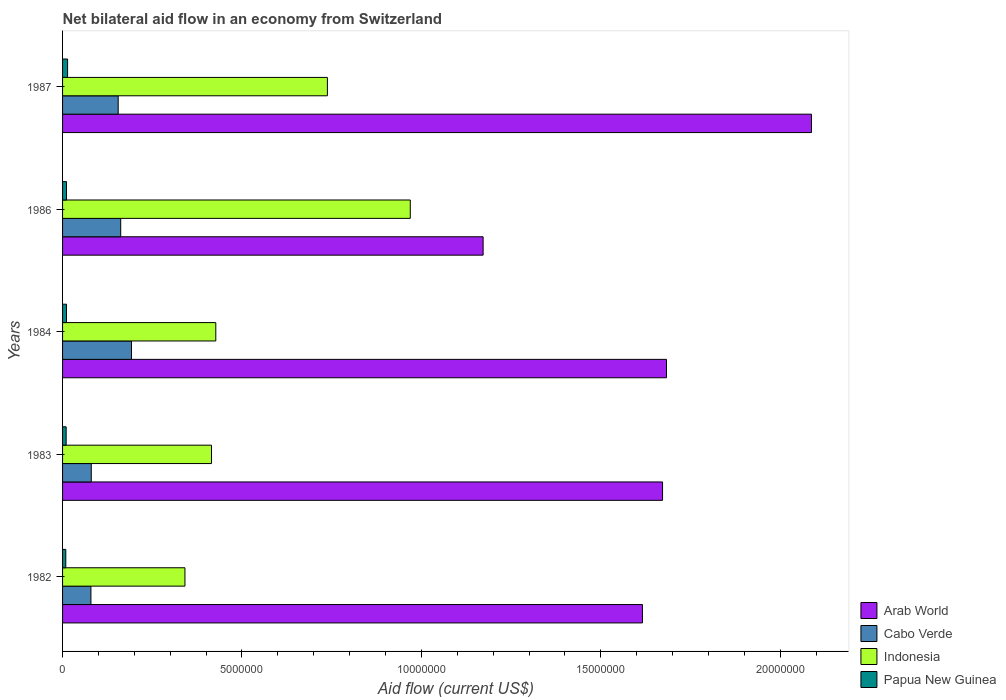How many different coloured bars are there?
Your response must be concise. 4. How many groups of bars are there?
Provide a succinct answer. 5. Are the number of bars on each tick of the Y-axis equal?
Your answer should be compact. Yes. In how many cases, is the number of bars for a given year not equal to the number of legend labels?
Your response must be concise. 0. What is the net bilateral aid flow in Arab World in 1987?
Your response must be concise. 2.09e+07. Across all years, what is the maximum net bilateral aid flow in Indonesia?
Keep it short and to the point. 9.69e+06. Across all years, what is the minimum net bilateral aid flow in Arab World?
Make the answer very short. 1.17e+07. In which year was the net bilateral aid flow in Papua New Guinea maximum?
Your response must be concise. 1987. What is the total net bilateral aid flow in Cabo Verde in the graph?
Provide a succinct answer. 6.68e+06. What is the difference between the net bilateral aid flow in Cabo Verde in 1987 and the net bilateral aid flow in Arab World in 1982?
Ensure brevity in your answer.  -1.46e+07. What is the average net bilateral aid flow in Indonesia per year?
Provide a short and direct response. 5.78e+06. In the year 1986, what is the difference between the net bilateral aid flow in Arab World and net bilateral aid flow in Papua New Guinea?
Ensure brevity in your answer.  1.16e+07. What is the ratio of the net bilateral aid flow in Arab World in 1984 to that in 1987?
Provide a succinct answer. 0.81. What is the difference between the highest and the second highest net bilateral aid flow in Cabo Verde?
Provide a short and direct response. 3.00e+05. What is the difference between the highest and the lowest net bilateral aid flow in Cabo Verde?
Offer a terse response. 1.13e+06. In how many years, is the net bilateral aid flow in Arab World greater than the average net bilateral aid flow in Arab World taken over all years?
Give a very brief answer. 3. Is the sum of the net bilateral aid flow in Cabo Verde in 1983 and 1987 greater than the maximum net bilateral aid flow in Papua New Guinea across all years?
Keep it short and to the point. Yes. Is it the case that in every year, the sum of the net bilateral aid flow in Papua New Guinea and net bilateral aid flow in Indonesia is greater than the sum of net bilateral aid flow in Arab World and net bilateral aid flow in Cabo Verde?
Your answer should be very brief. Yes. What does the 4th bar from the top in 1987 represents?
Give a very brief answer. Arab World. What does the 1st bar from the bottom in 1987 represents?
Give a very brief answer. Arab World. Is it the case that in every year, the sum of the net bilateral aid flow in Indonesia and net bilateral aid flow in Cabo Verde is greater than the net bilateral aid flow in Arab World?
Offer a very short reply. No. What is the difference between two consecutive major ticks on the X-axis?
Provide a short and direct response. 5.00e+06. Does the graph contain any zero values?
Make the answer very short. No. Where does the legend appear in the graph?
Your answer should be very brief. Bottom right. How many legend labels are there?
Ensure brevity in your answer.  4. How are the legend labels stacked?
Offer a terse response. Vertical. What is the title of the graph?
Keep it short and to the point. Net bilateral aid flow in an economy from Switzerland. What is the label or title of the Y-axis?
Your answer should be very brief. Years. What is the Aid flow (current US$) of Arab World in 1982?
Offer a very short reply. 1.62e+07. What is the Aid flow (current US$) in Cabo Verde in 1982?
Offer a terse response. 7.90e+05. What is the Aid flow (current US$) of Indonesia in 1982?
Ensure brevity in your answer.  3.41e+06. What is the Aid flow (current US$) in Papua New Guinea in 1982?
Offer a terse response. 9.00e+04. What is the Aid flow (current US$) of Arab World in 1983?
Ensure brevity in your answer.  1.67e+07. What is the Aid flow (current US$) of Indonesia in 1983?
Your answer should be compact. 4.15e+06. What is the Aid flow (current US$) in Arab World in 1984?
Your answer should be compact. 1.68e+07. What is the Aid flow (current US$) of Cabo Verde in 1984?
Offer a terse response. 1.92e+06. What is the Aid flow (current US$) of Indonesia in 1984?
Your answer should be compact. 4.27e+06. What is the Aid flow (current US$) of Papua New Guinea in 1984?
Your answer should be compact. 1.10e+05. What is the Aid flow (current US$) in Arab World in 1986?
Provide a succinct answer. 1.17e+07. What is the Aid flow (current US$) in Cabo Verde in 1986?
Your answer should be very brief. 1.62e+06. What is the Aid flow (current US$) in Indonesia in 1986?
Keep it short and to the point. 9.69e+06. What is the Aid flow (current US$) in Arab World in 1987?
Ensure brevity in your answer.  2.09e+07. What is the Aid flow (current US$) in Cabo Verde in 1987?
Your response must be concise. 1.55e+06. What is the Aid flow (current US$) of Indonesia in 1987?
Make the answer very short. 7.38e+06. Across all years, what is the maximum Aid flow (current US$) in Arab World?
Your response must be concise. 2.09e+07. Across all years, what is the maximum Aid flow (current US$) of Cabo Verde?
Your response must be concise. 1.92e+06. Across all years, what is the maximum Aid flow (current US$) of Indonesia?
Provide a short and direct response. 9.69e+06. Across all years, what is the maximum Aid flow (current US$) in Papua New Guinea?
Keep it short and to the point. 1.40e+05. Across all years, what is the minimum Aid flow (current US$) of Arab World?
Provide a short and direct response. 1.17e+07. Across all years, what is the minimum Aid flow (current US$) in Cabo Verde?
Keep it short and to the point. 7.90e+05. Across all years, what is the minimum Aid flow (current US$) of Indonesia?
Make the answer very short. 3.41e+06. Across all years, what is the minimum Aid flow (current US$) of Papua New Guinea?
Make the answer very short. 9.00e+04. What is the total Aid flow (current US$) in Arab World in the graph?
Make the answer very short. 8.23e+07. What is the total Aid flow (current US$) in Cabo Verde in the graph?
Offer a terse response. 6.68e+06. What is the total Aid flow (current US$) of Indonesia in the graph?
Keep it short and to the point. 2.89e+07. What is the difference between the Aid flow (current US$) of Arab World in 1982 and that in 1983?
Provide a succinct answer. -5.60e+05. What is the difference between the Aid flow (current US$) in Indonesia in 1982 and that in 1983?
Make the answer very short. -7.40e+05. What is the difference between the Aid flow (current US$) in Arab World in 1982 and that in 1984?
Your response must be concise. -6.70e+05. What is the difference between the Aid flow (current US$) of Cabo Verde in 1982 and that in 1984?
Keep it short and to the point. -1.13e+06. What is the difference between the Aid flow (current US$) of Indonesia in 1982 and that in 1984?
Give a very brief answer. -8.60e+05. What is the difference between the Aid flow (current US$) in Arab World in 1982 and that in 1986?
Provide a succinct answer. 4.44e+06. What is the difference between the Aid flow (current US$) of Cabo Verde in 1982 and that in 1986?
Give a very brief answer. -8.30e+05. What is the difference between the Aid flow (current US$) of Indonesia in 1982 and that in 1986?
Provide a short and direct response. -6.28e+06. What is the difference between the Aid flow (current US$) in Arab World in 1982 and that in 1987?
Offer a very short reply. -4.71e+06. What is the difference between the Aid flow (current US$) in Cabo Verde in 1982 and that in 1987?
Your response must be concise. -7.60e+05. What is the difference between the Aid flow (current US$) in Indonesia in 1982 and that in 1987?
Ensure brevity in your answer.  -3.97e+06. What is the difference between the Aid flow (current US$) in Cabo Verde in 1983 and that in 1984?
Make the answer very short. -1.12e+06. What is the difference between the Aid flow (current US$) in Indonesia in 1983 and that in 1984?
Offer a terse response. -1.20e+05. What is the difference between the Aid flow (current US$) in Papua New Guinea in 1983 and that in 1984?
Provide a short and direct response. -10000. What is the difference between the Aid flow (current US$) in Cabo Verde in 1983 and that in 1986?
Keep it short and to the point. -8.20e+05. What is the difference between the Aid flow (current US$) of Indonesia in 1983 and that in 1986?
Give a very brief answer. -5.54e+06. What is the difference between the Aid flow (current US$) in Papua New Guinea in 1983 and that in 1986?
Offer a terse response. -10000. What is the difference between the Aid flow (current US$) of Arab World in 1983 and that in 1987?
Your answer should be very brief. -4.15e+06. What is the difference between the Aid flow (current US$) of Cabo Verde in 1983 and that in 1987?
Your answer should be very brief. -7.50e+05. What is the difference between the Aid flow (current US$) in Indonesia in 1983 and that in 1987?
Offer a very short reply. -3.23e+06. What is the difference between the Aid flow (current US$) in Arab World in 1984 and that in 1986?
Provide a short and direct response. 5.11e+06. What is the difference between the Aid flow (current US$) of Indonesia in 1984 and that in 1986?
Your response must be concise. -5.42e+06. What is the difference between the Aid flow (current US$) in Papua New Guinea in 1984 and that in 1986?
Offer a very short reply. 0. What is the difference between the Aid flow (current US$) of Arab World in 1984 and that in 1987?
Your answer should be very brief. -4.04e+06. What is the difference between the Aid flow (current US$) in Indonesia in 1984 and that in 1987?
Make the answer very short. -3.11e+06. What is the difference between the Aid flow (current US$) in Papua New Guinea in 1984 and that in 1987?
Keep it short and to the point. -3.00e+04. What is the difference between the Aid flow (current US$) of Arab World in 1986 and that in 1987?
Ensure brevity in your answer.  -9.15e+06. What is the difference between the Aid flow (current US$) of Indonesia in 1986 and that in 1987?
Provide a succinct answer. 2.31e+06. What is the difference between the Aid flow (current US$) in Papua New Guinea in 1986 and that in 1987?
Offer a very short reply. -3.00e+04. What is the difference between the Aid flow (current US$) of Arab World in 1982 and the Aid flow (current US$) of Cabo Verde in 1983?
Offer a very short reply. 1.54e+07. What is the difference between the Aid flow (current US$) of Arab World in 1982 and the Aid flow (current US$) of Indonesia in 1983?
Make the answer very short. 1.20e+07. What is the difference between the Aid flow (current US$) in Arab World in 1982 and the Aid flow (current US$) in Papua New Guinea in 1983?
Make the answer very short. 1.61e+07. What is the difference between the Aid flow (current US$) of Cabo Verde in 1982 and the Aid flow (current US$) of Indonesia in 1983?
Your answer should be compact. -3.36e+06. What is the difference between the Aid flow (current US$) of Cabo Verde in 1982 and the Aid flow (current US$) of Papua New Guinea in 1983?
Ensure brevity in your answer.  6.90e+05. What is the difference between the Aid flow (current US$) of Indonesia in 1982 and the Aid flow (current US$) of Papua New Guinea in 1983?
Make the answer very short. 3.31e+06. What is the difference between the Aid flow (current US$) of Arab World in 1982 and the Aid flow (current US$) of Cabo Verde in 1984?
Provide a succinct answer. 1.42e+07. What is the difference between the Aid flow (current US$) in Arab World in 1982 and the Aid flow (current US$) in Indonesia in 1984?
Provide a short and direct response. 1.19e+07. What is the difference between the Aid flow (current US$) in Arab World in 1982 and the Aid flow (current US$) in Papua New Guinea in 1984?
Ensure brevity in your answer.  1.60e+07. What is the difference between the Aid flow (current US$) in Cabo Verde in 1982 and the Aid flow (current US$) in Indonesia in 1984?
Your response must be concise. -3.48e+06. What is the difference between the Aid flow (current US$) of Cabo Verde in 1982 and the Aid flow (current US$) of Papua New Guinea in 1984?
Keep it short and to the point. 6.80e+05. What is the difference between the Aid flow (current US$) of Indonesia in 1982 and the Aid flow (current US$) of Papua New Guinea in 1984?
Your answer should be compact. 3.30e+06. What is the difference between the Aid flow (current US$) in Arab World in 1982 and the Aid flow (current US$) in Cabo Verde in 1986?
Offer a very short reply. 1.45e+07. What is the difference between the Aid flow (current US$) in Arab World in 1982 and the Aid flow (current US$) in Indonesia in 1986?
Offer a terse response. 6.47e+06. What is the difference between the Aid flow (current US$) of Arab World in 1982 and the Aid flow (current US$) of Papua New Guinea in 1986?
Offer a terse response. 1.60e+07. What is the difference between the Aid flow (current US$) in Cabo Verde in 1982 and the Aid flow (current US$) in Indonesia in 1986?
Your answer should be very brief. -8.90e+06. What is the difference between the Aid flow (current US$) in Cabo Verde in 1982 and the Aid flow (current US$) in Papua New Guinea in 1986?
Your answer should be very brief. 6.80e+05. What is the difference between the Aid flow (current US$) in Indonesia in 1982 and the Aid flow (current US$) in Papua New Guinea in 1986?
Your answer should be very brief. 3.30e+06. What is the difference between the Aid flow (current US$) in Arab World in 1982 and the Aid flow (current US$) in Cabo Verde in 1987?
Give a very brief answer. 1.46e+07. What is the difference between the Aid flow (current US$) in Arab World in 1982 and the Aid flow (current US$) in Indonesia in 1987?
Your response must be concise. 8.78e+06. What is the difference between the Aid flow (current US$) of Arab World in 1982 and the Aid flow (current US$) of Papua New Guinea in 1987?
Your response must be concise. 1.60e+07. What is the difference between the Aid flow (current US$) in Cabo Verde in 1982 and the Aid flow (current US$) in Indonesia in 1987?
Make the answer very short. -6.59e+06. What is the difference between the Aid flow (current US$) of Cabo Verde in 1982 and the Aid flow (current US$) of Papua New Guinea in 1987?
Provide a short and direct response. 6.50e+05. What is the difference between the Aid flow (current US$) of Indonesia in 1982 and the Aid flow (current US$) of Papua New Guinea in 1987?
Offer a very short reply. 3.27e+06. What is the difference between the Aid flow (current US$) of Arab World in 1983 and the Aid flow (current US$) of Cabo Verde in 1984?
Give a very brief answer. 1.48e+07. What is the difference between the Aid flow (current US$) of Arab World in 1983 and the Aid flow (current US$) of Indonesia in 1984?
Ensure brevity in your answer.  1.24e+07. What is the difference between the Aid flow (current US$) in Arab World in 1983 and the Aid flow (current US$) in Papua New Guinea in 1984?
Make the answer very short. 1.66e+07. What is the difference between the Aid flow (current US$) of Cabo Verde in 1983 and the Aid flow (current US$) of Indonesia in 1984?
Ensure brevity in your answer.  -3.47e+06. What is the difference between the Aid flow (current US$) in Cabo Verde in 1983 and the Aid flow (current US$) in Papua New Guinea in 1984?
Keep it short and to the point. 6.90e+05. What is the difference between the Aid flow (current US$) in Indonesia in 1983 and the Aid flow (current US$) in Papua New Guinea in 1984?
Provide a succinct answer. 4.04e+06. What is the difference between the Aid flow (current US$) in Arab World in 1983 and the Aid flow (current US$) in Cabo Verde in 1986?
Your answer should be compact. 1.51e+07. What is the difference between the Aid flow (current US$) of Arab World in 1983 and the Aid flow (current US$) of Indonesia in 1986?
Offer a very short reply. 7.03e+06. What is the difference between the Aid flow (current US$) of Arab World in 1983 and the Aid flow (current US$) of Papua New Guinea in 1986?
Give a very brief answer. 1.66e+07. What is the difference between the Aid flow (current US$) in Cabo Verde in 1983 and the Aid flow (current US$) in Indonesia in 1986?
Provide a succinct answer. -8.89e+06. What is the difference between the Aid flow (current US$) of Cabo Verde in 1983 and the Aid flow (current US$) of Papua New Guinea in 1986?
Ensure brevity in your answer.  6.90e+05. What is the difference between the Aid flow (current US$) in Indonesia in 1983 and the Aid flow (current US$) in Papua New Guinea in 1986?
Ensure brevity in your answer.  4.04e+06. What is the difference between the Aid flow (current US$) of Arab World in 1983 and the Aid flow (current US$) of Cabo Verde in 1987?
Your answer should be compact. 1.52e+07. What is the difference between the Aid flow (current US$) in Arab World in 1983 and the Aid flow (current US$) in Indonesia in 1987?
Offer a terse response. 9.34e+06. What is the difference between the Aid flow (current US$) in Arab World in 1983 and the Aid flow (current US$) in Papua New Guinea in 1987?
Offer a terse response. 1.66e+07. What is the difference between the Aid flow (current US$) of Cabo Verde in 1983 and the Aid flow (current US$) of Indonesia in 1987?
Your response must be concise. -6.58e+06. What is the difference between the Aid flow (current US$) of Indonesia in 1983 and the Aid flow (current US$) of Papua New Guinea in 1987?
Give a very brief answer. 4.01e+06. What is the difference between the Aid flow (current US$) in Arab World in 1984 and the Aid flow (current US$) in Cabo Verde in 1986?
Give a very brief answer. 1.52e+07. What is the difference between the Aid flow (current US$) of Arab World in 1984 and the Aid flow (current US$) of Indonesia in 1986?
Make the answer very short. 7.14e+06. What is the difference between the Aid flow (current US$) of Arab World in 1984 and the Aid flow (current US$) of Papua New Guinea in 1986?
Provide a succinct answer. 1.67e+07. What is the difference between the Aid flow (current US$) of Cabo Verde in 1984 and the Aid flow (current US$) of Indonesia in 1986?
Ensure brevity in your answer.  -7.77e+06. What is the difference between the Aid flow (current US$) in Cabo Verde in 1984 and the Aid flow (current US$) in Papua New Guinea in 1986?
Offer a very short reply. 1.81e+06. What is the difference between the Aid flow (current US$) of Indonesia in 1984 and the Aid flow (current US$) of Papua New Guinea in 1986?
Provide a short and direct response. 4.16e+06. What is the difference between the Aid flow (current US$) of Arab World in 1984 and the Aid flow (current US$) of Cabo Verde in 1987?
Provide a succinct answer. 1.53e+07. What is the difference between the Aid flow (current US$) in Arab World in 1984 and the Aid flow (current US$) in Indonesia in 1987?
Your answer should be very brief. 9.45e+06. What is the difference between the Aid flow (current US$) in Arab World in 1984 and the Aid flow (current US$) in Papua New Guinea in 1987?
Offer a very short reply. 1.67e+07. What is the difference between the Aid flow (current US$) in Cabo Verde in 1984 and the Aid flow (current US$) in Indonesia in 1987?
Give a very brief answer. -5.46e+06. What is the difference between the Aid flow (current US$) of Cabo Verde in 1984 and the Aid flow (current US$) of Papua New Guinea in 1987?
Your answer should be compact. 1.78e+06. What is the difference between the Aid flow (current US$) of Indonesia in 1984 and the Aid flow (current US$) of Papua New Guinea in 1987?
Give a very brief answer. 4.13e+06. What is the difference between the Aid flow (current US$) of Arab World in 1986 and the Aid flow (current US$) of Cabo Verde in 1987?
Your answer should be very brief. 1.02e+07. What is the difference between the Aid flow (current US$) in Arab World in 1986 and the Aid flow (current US$) in Indonesia in 1987?
Provide a short and direct response. 4.34e+06. What is the difference between the Aid flow (current US$) in Arab World in 1986 and the Aid flow (current US$) in Papua New Guinea in 1987?
Make the answer very short. 1.16e+07. What is the difference between the Aid flow (current US$) of Cabo Verde in 1986 and the Aid flow (current US$) of Indonesia in 1987?
Keep it short and to the point. -5.76e+06. What is the difference between the Aid flow (current US$) in Cabo Verde in 1986 and the Aid flow (current US$) in Papua New Guinea in 1987?
Make the answer very short. 1.48e+06. What is the difference between the Aid flow (current US$) in Indonesia in 1986 and the Aid flow (current US$) in Papua New Guinea in 1987?
Provide a succinct answer. 9.55e+06. What is the average Aid flow (current US$) of Arab World per year?
Provide a succinct answer. 1.65e+07. What is the average Aid flow (current US$) of Cabo Verde per year?
Provide a short and direct response. 1.34e+06. What is the average Aid flow (current US$) in Indonesia per year?
Keep it short and to the point. 5.78e+06. In the year 1982, what is the difference between the Aid flow (current US$) in Arab World and Aid flow (current US$) in Cabo Verde?
Make the answer very short. 1.54e+07. In the year 1982, what is the difference between the Aid flow (current US$) in Arab World and Aid flow (current US$) in Indonesia?
Make the answer very short. 1.28e+07. In the year 1982, what is the difference between the Aid flow (current US$) of Arab World and Aid flow (current US$) of Papua New Guinea?
Ensure brevity in your answer.  1.61e+07. In the year 1982, what is the difference between the Aid flow (current US$) in Cabo Verde and Aid flow (current US$) in Indonesia?
Your answer should be compact. -2.62e+06. In the year 1982, what is the difference between the Aid flow (current US$) of Cabo Verde and Aid flow (current US$) of Papua New Guinea?
Ensure brevity in your answer.  7.00e+05. In the year 1982, what is the difference between the Aid flow (current US$) in Indonesia and Aid flow (current US$) in Papua New Guinea?
Offer a very short reply. 3.32e+06. In the year 1983, what is the difference between the Aid flow (current US$) of Arab World and Aid flow (current US$) of Cabo Verde?
Ensure brevity in your answer.  1.59e+07. In the year 1983, what is the difference between the Aid flow (current US$) of Arab World and Aid flow (current US$) of Indonesia?
Keep it short and to the point. 1.26e+07. In the year 1983, what is the difference between the Aid flow (current US$) of Arab World and Aid flow (current US$) of Papua New Guinea?
Offer a very short reply. 1.66e+07. In the year 1983, what is the difference between the Aid flow (current US$) in Cabo Verde and Aid flow (current US$) in Indonesia?
Your answer should be very brief. -3.35e+06. In the year 1983, what is the difference between the Aid flow (current US$) in Indonesia and Aid flow (current US$) in Papua New Guinea?
Make the answer very short. 4.05e+06. In the year 1984, what is the difference between the Aid flow (current US$) of Arab World and Aid flow (current US$) of Cabo Verde?
Offer a terse response. 1.49e+07. In the year 1984, what is the difference between the Aid flow (current US$) in Arab World and Aid flow (current US$) in Indonesia?
Your answer should be very brief. 1.26e+07. In the year 1984, what is the difference between the Aid flow (current US$) of Arab World and Aid flow (current US$) of Papua New Guinea?
Provide a short and direct response. 1.67e+07. In the year 1984, what is the difference between the Aid flow (current US$) in Cabo Verde and Aid flow (current US$) in Indonesia?
Offer a very short reply. -2.35e+06. In the year 1984, what is the difference between the Aid flow (current US$) in Cabo Verde and Aid flow (current US$) in Papua New Guinea?
Give a very brief answer. 1.81e+06. In the year 1984, what is the difference between the Aid flow (current US$) in Indonesia and Aid flow (current US$) in Papua New Guinea?
Offer a terse response. 4.16e+06. In the year 1986, what is the difference between the Aid flow (current US$) of Arab World and Aid flow (current US$) of Cabo Verde?
Your answer should be very brief. 1.01e+07. In the year 1986, what is the difference between the Aid flow (current US$) in Arab World and Aid flow (current US$) in Indonesia?
Your answer should be compact. 2.03e+06. In the year 1986, what is the difference between the Aid flow (current US$) in Arab World and Aid flow (current US$) in Papua New Guinea?
Your answer should be compact. 1.16e+07. In the year 1986, what is the difference between the Aid flow (current US$) in Cabo Verde and Aid flow (current US$) in Indonesia?
Provide a short and direct response. -8.07e+06. In the year 1986, what is the difference between the Aid flow (current US$) in Cabo Verde and Aid flow (current US$) in Papua New Guinea?
Offer a terse response. 1.51e+06. In the year 1986, what is the difference between the Aid flow (current US$) of Indonesia and Aid flow (current US$) of Papua New Guinea?
Keep it short and to the point. 9.58e+06. In the year 1987, what is the difference between the Aid flow (current US$) of Arab World and Aid flow (current US$) of Cabo Verde?
Keep it short and to the point. 1.93e+07. In the year 1987, what is the difference between the Aid flow (current US$) in Arab World and Aid flow (current US$) in Indonesia?
Offer a terse response. 1.35e+07. In the year 1987, what is the difference between the Aid flow (current US$) in Arab World and Aid flow (current US$) in Papua New Guinea?
Keep it short and to the point. 2.07e+07. In the year 1987, what is the difference between the Aid flow (current US$) in Cabo Verde and Aid flow (current US$) in Indonesia?
Offer a terse response. -5.83e+06. In the year 1987, what is the difference between the Aid flow (current US$) of Cabo Verde and Aid flow (current US$) of Papua New Guinea?
Provide a short and direct response. 1.41e+06. In the year 1987, what is the difference between the Aid flow (current US$) of Indonesia and Aid flow (current US$) of Papua New Guinea?
Provide a short and direct response. 7.24e+06. What is the ratio of the Aid flow (current US$) of Arab World in 1982 to that in 1983?
Your answer should be very brief. 0.97. What is the ratio of the Aid flow (current US$) of Cabo Verde in 1982 to that in 1983?
Give a very brief answer. 0.99. What is the ratio of the Aid flow (current US$) in Indonesia in 1982 to that in 1983?
Keep it short and to the point. 0.82. What is the ratio of the Aid flow (current US$) in Arab World in 1982 to that in 1984?
Your answer should be compact. 0.96. What is the ratio of the Aid flow (current US$) of Cabo Verde in 1982 to that in 1984?
Offer a terse response. 0.41. What is the ratio of the Aid flow (current US$) in Indonesia in 1982 to that in 1984?
Your answer should be compact. 0.8. What is the ratio of the Aid flow (current US$) in Papua New Guinea in 1982 to that in 1984?
Offer a very short reply. 0.82. What is the ratio of the Aid flow (current US$) of Arab World in 1982 to that in 1986?
Provide a succinct answer. 1.38. What is the ratio of the Aid flow (current US$) in Cabo Verde in 1982 to that in 1986?
Provide a succinct answer. 0.49. What is the ratio of the Aid flow (current US$) of Indonesia in 1982 to that in 1986?
Your answer should be compact. 0.35. What is the ratio of the Aid flow (current US$) of Papua New Guinea in 1982 to that in 1986?
Your response must be concise. 0.82. What is the ratio of the Aid flow (current US$) in Arab World in 1982 to that in 1987?
Your answer should be very brief. 0.77. What is the ratio of the Aid flow (current US$) in Cabo Verde in 1982 to that in 1987?
Ensure brevity in your answer.  0.51. What is the ratio of the Aid flow (current US$) of Indonesia in 1982 to that in 1987?
Keep it short and to the point. 0.46. What is the ratio of the Aid flow (current US$) in Papua New Guinea in 1982 to that in 1987?
Provide a succinct answer. 0.64. What is the ratio of the Aid flow (current US$) in Cabo Verde in 1983 to that in 1984?
Your response must be concise. 0.42. What is the ratio of the Aid flow (current US$) in Indonesia in 1983 to that in 1984?
Ensure brevity in your answer.  0.97. What is the ratio of the Aid flow (current US$) of Papua New Guinea in 1983 to that in 1984?
Your answer should be very brief. 0.91. What is the ratio of the Aid flow (current US$) of Arab World in 1983 to that in 1986?
Your response must be concise. 1.43. What is the ratio of the Aid flow (current US$) of Cabo Verde in 1983 to that in 1986?
Offer a very short reply. 0.49. What is the ratio of the Aid flow (current US$) of Indonesia in 1983 to that in 1986?
Your answer should be very brief. 0.43. What is the ratio of the Aid flow (current US$) in Arab World in 1983 to that in 1987?
Your answer should be compact. 0.8. What is the ratio of the Aid flow (current US$) in Cabo Verde in 1983 to that in 1987?
Provide a succinct answer. 0.52. What is the ratio of the Aid flow (current US$) of Indonesia in 1983 to that in 1987?
Offer a very short reply. 0.56. What is the ratio of the Aid flow (current US$) in Arab World in 1984 to that in 1986?
Give a very brief answer. 1.44. What is the ratio of the Aid flow (current US$) of Cabo Verde in 1984 to that in 1986?
Provide a short and direct response. 1.19. What is the ratio of the Aid flow (current US$) of Indonesia in 1984 to that in 1986?
Ensure brevity in your answer.  0.44. What is the ratio of the Aid flow (current US$) of Papua New Guinea in 1984 to that in 1986?
Offer a terse response. 1. What is the ratio of the Aid flow (current US$) in Arab World in 1984 to that in 1987?
Your response must be concise. 0.81. What is the ratio of the Aid flow (current US$) of Cabo Verde in 1984 to that in 1987?
Provide a succinct answer. 1.24. What is the ratio of the Aid flow (current US$) in Indonesia in 1984 to that in 1987?
Give a very brief answer. 0.58. What is the ratio of the Aid flow (current US$) in Papua New Guinea in 1984 to that in 1987?
Your answer should be compact. 0.79. What is the ratio of the Aid flow (current US$) of Arab World in 1986 to that in 1987?
Offer a very short reply. 0.56. What is the ratio of the Aid flow (current US$) in Cabo Verde in 1986 to that in 1987?
Offer a very short reply. 1.05. What is the ratio of the Aid flow (current US$) in Indonesia in 1986 to that in 1987?
Your answer should be compact. 1.31. What is the ratio of the Aid flow (current US$) in Papua New Guinea in 1986 to that in 1987?
Offer a very short reply. 0.79. What is the difference between the highest and the second highest Aid flow (current US$) in Arab World?
Offer a very short reply. 4.04e+06. What is the difference between the highest and the second highest Aid flow (current US$) in Cabo Verde?
Your response must be concise. 3.00e+05. What is the difference between the highest and the second highest Aid flow (current US$) of Indonesia?
Provide a short and direct response. 2.31e+06. What is the difference between the highest and the lowest Aid flow (current US$) in Arab World?
Ensure brevity in your answer.  9.15e+06. What is the difference between the highest and the lowest Aid flow (current US$) of Cabo Verde?
Your answer should be compact. 1.13e+06. What is the difference between the highest and the lowest Aid flow (current US$) in Indonesia?
Provide a succinct answer. 6.28e+06. 